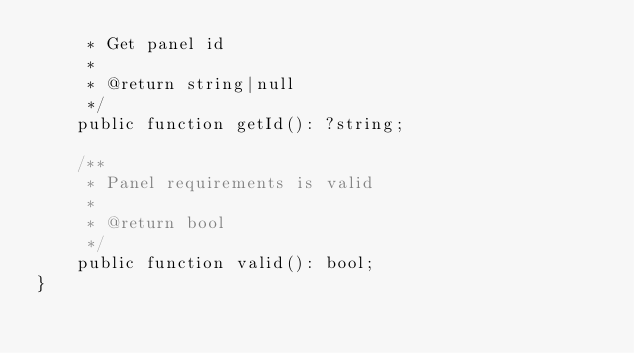Convert code to text. <code><loc_0><loc_0><loc_500><loc_500><_PHP_>     * Get panel id
     *
     * @return string|null
     */
    public function getId(): ?string;

    /**
     * Panel requirements is valid
     *
     * @return bool
     */
    public function valid(): bool;
}
</code> 